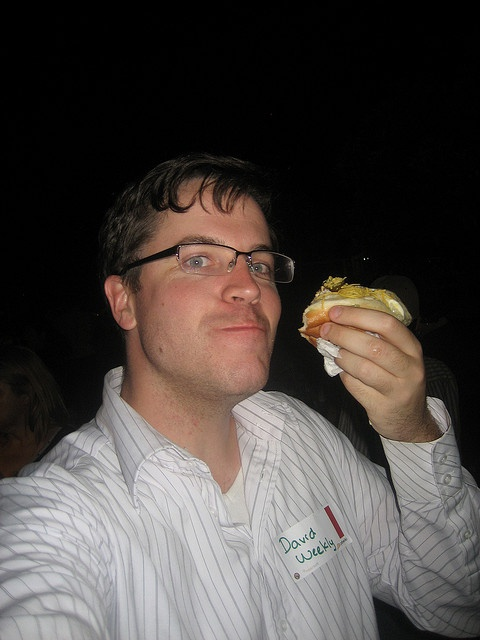Describe the objects in this image and their specific colors. I can see people in black, darkgray, gray, and lightgray tones, sandwich in black, tan, olive, and gray tones, and hot dog in black, tan, and olive tones in this image. 